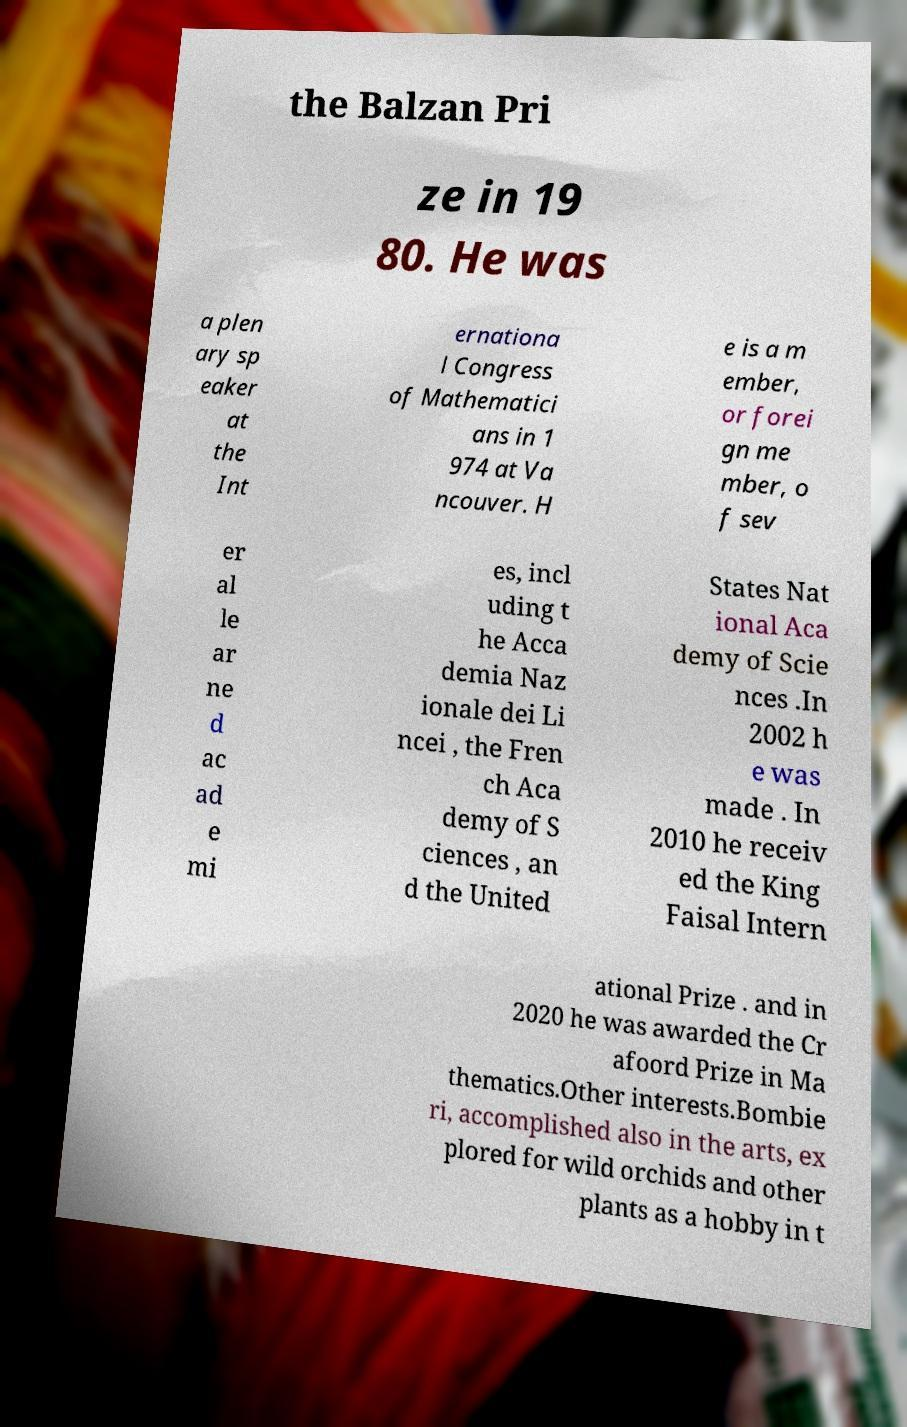Can you read and provide the text displayed in the image?This photo seems to have some interesting text. Can you extract and type it out for me? the Balzan Pri ze in 19 80. He was a plen ary sp eaker at the Int ernationa l Congress of Mathematici ans in 1 974 at Va ncouver. H e is a m ember, or forei gn me mber, o f sev er al le ar ne d ac ad e mi es, incl uding t he Acca demia Naz ionale dei Li ncei , the Fren ch Aca demy of S ciences , an d the United States Nat ional Aca demy of Scie nces .In 2002 h e was made . In 2010 he receiv ed the King Faisal Intern ational Prize . and in 2020 he was awarded the Cr afoord Prize in Ma thematics.Other interests.Bombie ri, accomplished also in the arts, ex plored for wild orchids and other plants as a hobby in t 